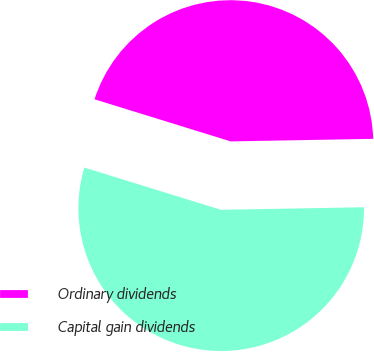Convert chart. <chart><loc_0><loc_0><loc_500><loc_500><pie_chart><fcel>Ordinary dividends<fcel>Capital gain dividends<nl><fcel>44.94%<fcel>55.06%<nl></chart> 